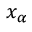<formula> <loc_0><loc_0><loc_500><loc_500>x _ { \alpha }</formula> 